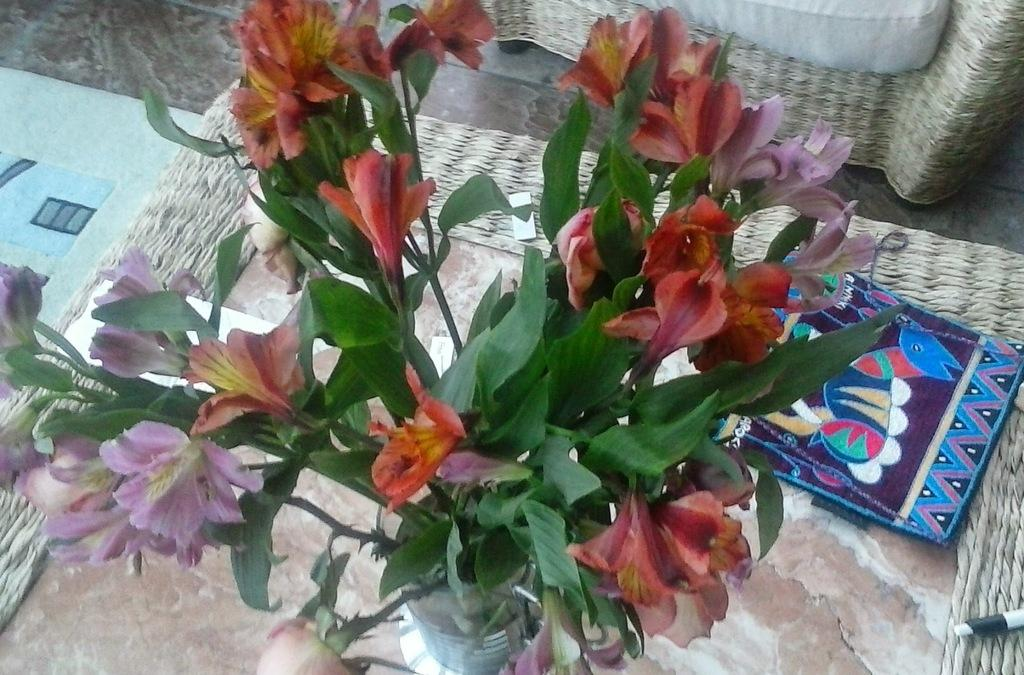What object can be seen in the image that might be used for carrying items? There is a bag in the image that might be used for carrying items. What type of decorative elements are present in the image? There are flowers of different colors in the image. What type of furniture is visible in the image? There is a sofa in the image. How many dimes are scattered on the sofa in the image? There are no dimes present in the image; it features a bag, flowers, and a sofa. What type of dish is being prepared by the grandfather in the image? There is no grandfather or dish being prepared in the image. 